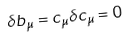Convert formula to latex. <formula><loc_0><loc_0><loc_500><loc_500>\delta b _ { \mu } = c _ { \mu } \delta c _ { \mu } = 0</formula> 